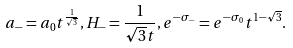<formula> <loc_0><loc_0><loc_500><loc_500>a _ { - } = a _ { 0 } t ^ { \frac { 1 } { \sqrt { 3 } } } , H _ { - } = \frac { 1 } { \sqrt { 3 } t } , e ^ { - \sigma _ { - } } = e ^ { - \sigma _ { 0 } } t ^ { 1 - \sqrt { 3 } } .</formula> 